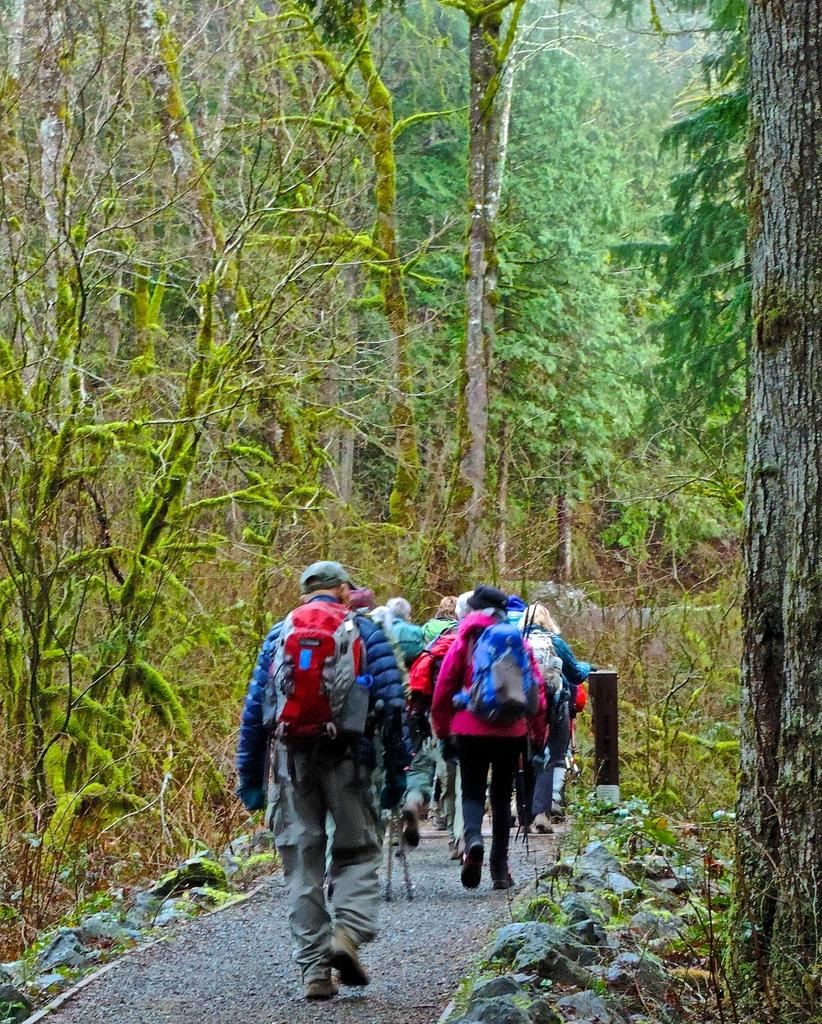What are the people in the image doing? The people in the image are walking. What are the people carrying while walking? The people are carrying bags. What type of vegetation can be seen in the image? There are plants and trees in the image. What structure is present in the image? There is a pole in the image. What book is the person reading while walking in the image? There is no book present in the image. 